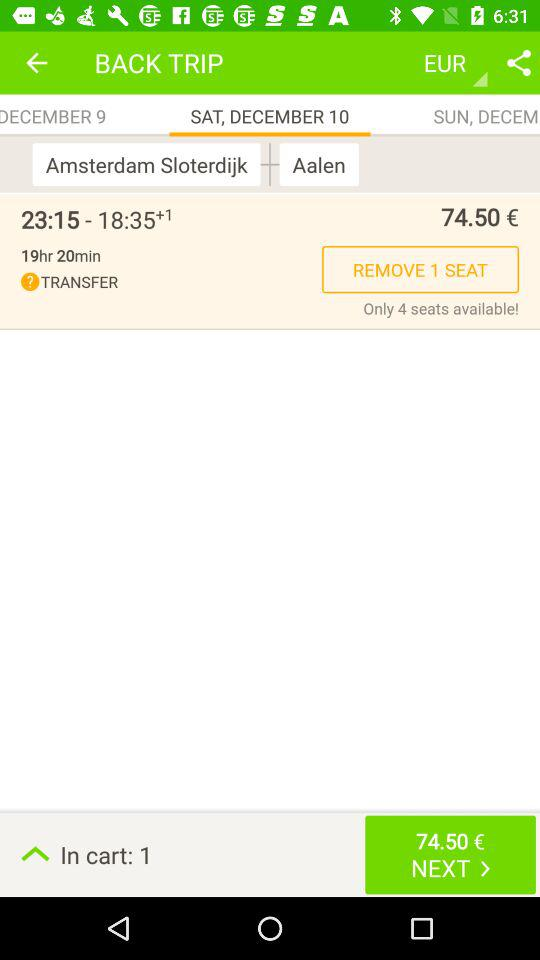What is the fare for the trip from Amsterdam to Aalen? The fare for the trip from Amsterdam to Aalen is 74.50 euros. 